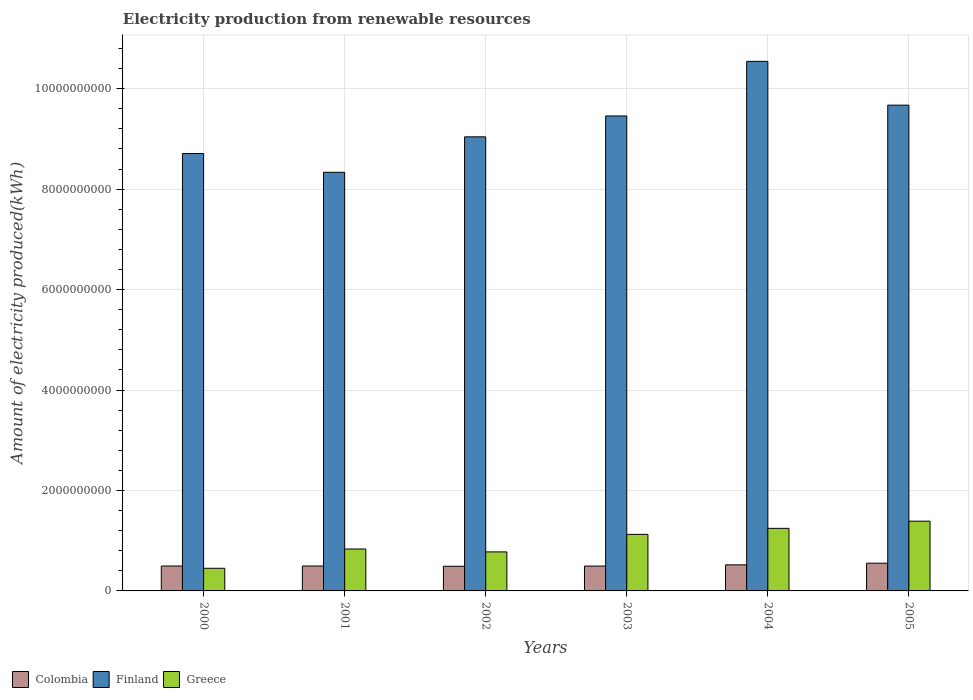How many groups of bars are there?
Ensure brevity in your answer.  6. Are the number of bars per tick equal to the number of legend labels?
Make the answer very short. Yes. Are the number of bars on each tick of the X-axis equal?
Ensure brevity in your answer.  Yes. How many bars are there on the 3rd tick from the left?
Offer a very short reply. 3. How many bars are there on the 4th tick from the right?
Your response must be concise. 3. What is the label of the 5th group of bars from the left?
Offer a very short reply. 2004. What is the amount of electricity produced in Finland in 2000?
Your answer should be very brief. 8.71e+09. Across all years, what is the maximum amount of electricity produced in Colombia?
Offer a terse response. 5.52e+08. Across all years, what is the minimum amount of electricity produced in Finland?
Offer a terse response. 8.34e+09. In which year was the amount of electricity produced in Colombia minimum?
Keep it short and to the point. 2002. What is the total amount of electricity produced in Greece in the graph?
Offer a very short reply. 5.82e+09. What is the difference between the amount of electricity produced in Finland in 2002 and that in 2003?
Make the answer very short. -4.16e+08. What is the difference between the amount of electricity produced in Colombia in 2003 and the amount of electricity produced in Finland in 2004?
Offer a terse response. -1.00e+1. What is the average amount of electricity produced in Colombia per year?
Make the answer very short. 5.08e+08. In the year 2004, what is the difference between the amount of electricity produced in Colombia and amount of electricity produced in Finland?
Provide a succinct answer. -1.00e+1. In how many years, is the amount of electricity produced in Finland greater than 5200000000 kWh?
Your response must be concise. 6. What is the ratio of the amount of electricity produced in Greece in 2001 to that in 2002?
Your answer should be very brief. 1.07. What is the difference between the highest and the second highest amount of electricity produced in Colombia?
Make the answer very short. 3.30e+07. What is the difference between the highest and the lowest amount of electricity produced in Greece?
Your answer should be compact. 9.38e+08. Is the sum of the amount of electricity produced in Finland in 2000 and 2005 greater than the maximum amount of electricity produced in Greece across all years?
Your response must be concise. Yes. What does the 3rd bar from the left in 2005 represents?
Provide a succinct answer. Greece. What does the 2nd bar from the right in 2000 represents?
Your answer should be compact. Finland. How many bars are there?
Provide a succinct answer. 18. What is the difference between two consecutive major ticks on the Y-axis?
Offer a very short reply. 2.00e+09. Are the values on the major ticks of Y-axis written in scientific E-notation?
Give a very brief answer. No. Where does the legend appear in the graph?
Offer a terse response. Bottom left. How are the legend labels stacked?
Your answer should be very brief. Horizontal. What is the title of the graph?
Your answer should be compact. Electricity production from renewable resources. What is the label or title of the X-axis?
Your answer should be compact. Years. What is the label or title of the Y-axis?
Ensure brevity in your answer.  Amount of electricity produced(kWh). What is the Amount of electricity produced(kWh) of Colombia in 2000?
Your response must be concise. 4.96e+08. What is the Amount of electricity produced(kWh) of Finland in 2000?
Offer a very short reply. 8.71e+09. What is the Amount of electricity produced(kWh) of Greece in 2000?
Ensure brevity in your answer.  4.51e+08. What is the Amount of electricity produced(kWh) in Colombia in 2001?
Make the answer very short. 4.96e+08. What is the Amount of electricity produced(kWh) of Finland in 2001?
Your response must be concise. 8.34e+09. What is the Amount of electricity produced(kWh) in Greece in 2001?
Provide a short and direct response. 8.35e+08. What is the Amount of electricity produced(kWh) of Colombia in 2002?
Your response must be concise. 4.91e+08. What is the Amount of electricity produced(kWh) of Finland in 2002?
Ensure brevity in your answer.  9.04e+09. What is the Amount of electricity produced(kWh) in Greece in 2002?
Give a very brief answer. 7.77e+08. What is the Amount of electricity produced(kWh) of Colombia in 2003?
Offer a terse response. 4.95e+08. What is the Amount of electricity produced(kWh) of Finland in 2003?
Make the answer very short. 9.46e+09. What is the Amount of electricity produced(kWh) of Greece in 2003?
Your answer should be compact. 1.13e+09. What is the Amount of electricity produced(kWh) of Colombia in 2004?
Offer a very short reply. 5.19e+08. What is the Amount of electricity produced(kWh) of Finland in 2004?
Make the answer very short. 1.05e+1. What is the Amount of electricity produced(kWh) in Greece in 2004?
Your answer should be compact. 1.25e+09. What is the Amount of electricity produced(kWh) in Colombia in 2005?
Your response must be concise. 5.52e+08. What is the Amount of electricity produced(kWh) of Finland in 2005?
Ensure brevity in your answer.  9.67e+09. What is the Amount of electricity produced(kWh) of Greece in 2005?
Offer a terse response. 1.39e+09. Across all years, what is the maximum Amount of electricity produced(kWh) of Colombia?
Provide a short and direct response. 5.52e+08. Across all years, what is the maximum Amount of electricity produced(kWh) in Finland?
Make the answer very short. 1.05e+1. Across all years, what is the maximum Amount of electricity produced(kWh) in Greece?
Ensure brevity in your answer.  1.39e+09. Across all years, what is the minimum Amount of electricity produced(kWh) in Colombia?
Provide a short and direct response. 4.91e+08. Across all years, what is the minimum Amount of electricity produced(kWh) in Finland?
Your answer should be very brief. 8.34e+09. Across all years, what is the minimum Amount of electricity produced(kWh) in Greece?
Provide a succinct answer. 4.51e+08. What is the total Amount of electricity produced(kWh) in Colombia in the graph?
Your response must be concise. 3.05e+09. What is the total Amount of electricity produced(kWh) in Finland in the graph?
Your answer should be compact. 5.58e+1. What is the total Amount of electricity produced(kWh) in Greece in the graph?
Offer a terse response. 5.82e+09. What is the difference between the Amount of electricity produced(kWh) of Finland in 2000 and that in 2001?
Your response must be concise. 3.74e+08. What is the difference between the Amount of electricity produced(kWh) in Greece in 2000 and that in 2001?
Provide a short and direct response. -3.84e+08. What is the difference between the Amount of electricity produced(kWh) of Colombia in 2000 and that in 2002?
Your answer should be very brief. 5.00e+06. What is the difference between the Amount of electricity produced(kWh) in Finland in 2000 and that in 2002?
Offer a terse response. -3.32e+08. What is the difference between the Amount of electricity produced(kWh) of Greece in 2000 and that in 2002?
Give a very brief answer. -3.26e+08. What is the difference between the Amount of electricity produced(kWh) of Colombia in 2000 and that in 2003?
Your answer should be very brief. 1.00e+06. What is the difference between the Amount of electricity produced(kWh) of Finland in 2000 and that in 2003?
Make the answer very short. -7.48e+08. What is the difference between the Amount of electricity produced(kWh) of Greece in 2000 and that in 2003?
Give a very brief answer. -6.75e+08. What is the difference between the Amount of electricity produced(kWh) of Colombia in 2000 and that in 2004?
Provide a succinct answer. -2.30e+07. What is the difference between the Amount of electricity produced(kWh) of Finland in 2000 and that in 2004?
Offer a very short reply. -1.84e+09. What is the difference between the Amount of electricity produced(kWh) in Greece in 2000 and that in 2004?
Your answer should be compact. -7.95e+08. What is the difference between the Amount of electricity produced(kWh) of Colombia in 2000 and that in 2005?
Ensure brevity in your answer.  -5.60e+07. What is the difference between the Amount of electricity produced(kWh) in Finland in 2000 and that in 2005?
Make the answer very short. -9.63e+08. What is the difference between the Amount of electricity produced(kWh) in Greece in 2000 and that in 2005?
Keep it short and to the point. -9.38e+08. What is the difference between the Amount of electricity produced(kWh) of Finland in 2001 and that in 2002?
Your answer should be compact. -7.06e+08. What is the difference between the Amount of electricity produced(kWh) in Greece in 2001 and that in 2002?
Your response must be concise. 5.80e+07. What is the difference between the Amount of electricity produced(kWh) in Finland in 2001 and that in 2003?
Ensure brevity in your answer.  -1.12e+09. What is the difference between the Amount of electricity produced(kWh) of Greece in 2001 and that in 2003?
Provide a succinct answer. -2.91e+08. What is the difference between the Amount of electricity produced(kWh) in Colombia in 2001 and that in 2004?
Your answer should be compact. -2.30e+07. What is the difference between the Amount of electricity produced(kWh) of Finland in 2001 and that in 2004?
Provide a succinct answer. -2.21e+09. What is the difference between the Amount of electricity produced(kWh) in Greece in 2001 and that in 2004?
Provide a succinct answer. -4.11e+08. What is the difference between the Amount of electricity produced(kWh) of Colombia in 2001 and that in 2005?
Your answer should be compact. -5.60e+07. What is the difference between the Amount of electricity produced(kWh) in Finland in 2001 and that in 2005?
Provide a succinct answer. -1.34e+09. What is the difference between the Amount of electricity produced(kWh) in Greece in 2001 and that in 2005?
Your answer should be compact. -5.54e+08. What is the difference between the Amount of electricity produced(kWh) of Colombia in 2002 and that in 2003?
Give a very brief answer. -4.00e+06. What is the difference between the Amount of electricity produced(kWh) of Finland in 2002 and that in 2003?
Your answer should be very brief. -4.16e+08. What is the difference between the Amount of electricity produced(kWh) of Greece in 2002 and that in 2003?
Provide a succinct answer. -3.49e+08. What is the difference between the Amount of electricity produced(kWh) of Colombia in 2002 and that in 2004?
Keep it short and to the point. -2.80e+07. What is the difference between the Amount of electricity produced(kWh) of Finland in 2002 and that in 2004?
Your answer should be compact. -1.50e+09. What is the difference between the Amount of electricity produced(kWh) in Greece in 2002 and that in 2004?
Your response must be concise. -4.69e+08. What is the difference between the Amount of electricity produced(kWh) in Colombia in 2002 and that in 2005?
Offer a terse response. -6.10e+07. What is the difference between the Amount of electricity produced(kWh) of Finland in 2002 and that in 2005?
Offer a very short reply. -6.31e+08. What is the difference between the Amount of electricity produced(kWh) of Greece in 2002 and that in 2005?
Provide a short and direct response. -6.12e+08. What is the difference between the Amount of electricity produced(kWh) of Colombia in 2003 and that in 2004?
Offer a terse response. -2.40e+07. What is the difference between the Amount of electricity produced(kWh) of Finland in 2003 and that in 2004?
Your response must be concise. -1.09e+09. What is the difference between the Amount of electricity produced(kWh) in Greece in 2003 and that in 2004?
Your answer should be compact. -1.20e+08. What is the difference between the Amount of electricity produced(kWh) of Colombia in 2003 and that in 2005?
Provide a short and direct response. -5.70e+07. What is the difference between the Amount of electricity produced(kWh) in Finland in 2003 and that in 2005?
Make the answer very short. -2.15e+08. What is the difference between the Amount of electricity produced(kWh) in Greece in 2003 and that in 2005?
Keep it short and to the point. -2.63e+08. What is the difference between the Amount of electricity produced(kWh) in Colombia in 2004 and that in 2005?
Provide a succinct answer. -3.30e+07. What is the difference between the Amount of electricity produced(kWh) in Finland in 2004 and that in 2005?
Your response must be concise. 8.72e+08. What is the difference between the Amount of electricity produced(kWh) in Greece in 2004 and that in 2005?
Provide a short and direct response. -1.43e+08. What is the difference between the Amount of electricity produced(kWh) in Colombia in 2000 and the Amount of electricity produced(kWh) in Finland in 2001?
Keep it short and to the point. -7.84e+09. What is the difference between the Amount of electricity produced(kWh) in Colombia in 2000 and the Amount of electricity produced(kWh) in Greece in 2001?
Keep it short and to the point. -3.39e+08. What is the difference between the Amount of electricity produced(kWh) in Finland in 2000 and the Amount of electricity produced(kWh) in Greece in 2001?
Provide a short and direct response. 7.88e+09. What is the difference between the Amount of electricity produced(kWh) in Colombia in 2000 and the Amount of electricity produced(kWh) in Finland in 2002?
Ensure brevity in your answer.  -8.55e+09. What is the difference between the Amount of electricity produced(kWh) in Colombia in 2000 and the Amount of electricity produced(kWh) in Greece in 2002?
Your response must be concise. -2.81e+08. What is the difference between the Amount of electricity produced(kWh) in Finland in 2000 and the Amount of electricity produced(kWh) in Greece in 2002?
Your answer should be very brief. 7.93e+09. What is the difference between the Amount of electricity produced(kWh) in Colombia in 2000 and the Amount of electricity produced(kWh) in Finland in 2003?
Provide a short and direct response. -8.96e+09. What is the difference between the Amount of electricity produced(kWh) in Colombia in 2000 and the Amount of electricity produced(kWh) in Greece in 2003?
Offer a very short reply. -6.30e+08. What is the difference between the Amount of electricity produced(kWh) in Finland in 2000 and the Amount of electricity produced(kWh) in Greece in 2003?
Give a very brief answer. 7.58e+09. What is the difference between the Amount of electricity produced(kWh) of Colombia in 2000 and the Amount of electricity produced(kWh) of Finland in 2004?
Offer a very short reply. -1.00e+1. What is the difference between the Amount of electricity produced(kWh) of Colombia in 2000 and the Amount of electricity produced(kWh) of Greece in 2004?
Offer a very short reply. -7.50e+08. What is the difference between the Amount of electricity produced(kWh) of Finland in 2000 and the Amount of electricity produced(kWh) of Greece in 2004?
Offer a terse response. 7.46e+09. What is the difference between the Amount of electricity produced(kWh) of Colombia in 2000 and the Amount of electricity produced(kWh) of Finland in 2005?
Make the answer very short. -9.18e+09. What is the difference between the Amount of electricity produced(kWh) in Colombia in 2000 and the Amount of electricity produced(kWh) in Greece in 2005?
Give a very brief answer. -8.93e+08. What is the difference between the Amount of electricity produced(kWh) in Finland in 2000 and the Amount of electricity produced(kWh) in Greece in 2005?
Provide a short and direct response. 7.32e+09. What is the difference between the Amount of electricity produced(kWh) in Colombia in 2001 and the Amount of electricity produced(kWh) in Finland in 2002?
Provide a succinct answer. -8.55e+09. What is the difference between the Amount of electricity produced(kWh) in Colombia in 2001 and the Amount of electricity produced(kWh) in Greece in 2002?
Keep it short and to the point. -2.81e+08. What is the difference between the Amount of electricity produced(kWh) in Finland in 2001 and the Amount of electricity produced(kWh) in Greece in 2002?
Ensure brevity in your answer.  7.56e+09. What is the difference between the Amount of electricity produced(kWh) in Colombia in 2001 and the Amount of electricity produced(kWh) in Finland in 2003?
Offer a very short reply. -8.96e+09. What is the difference between the Amount of electricity produced(kWh) in Colombia in 2001 and the Amount of electricity produced(kWh) in Greece in 2003?
Make the answer very short. -6.30e+08. What is the difference between the Amount of electricity produced(kWh) in Finland in 2001 and the Amount of electricity produced(kWh) in Greece in 2003?
Offer a very short reply. 7.21e+09. What is the difference between the Amount of electricity produced(kWh) in Colombia in 2001 and the Amount of electricity produced(kWh) in Finland in 2004?
Offer a very short reply. -1.00e+1. What is the difference between the Amount of electricity produced(kWh) of Colombia in 2001 and the Amount of electricity produced(kWh) of Greece in 2004?
Offer a terse response. -7.50e+08. What is the difference between the Amount of electricity produced(kWh) in Finland in 2001 and the Amount of electricity produced(kWh) in Greece in 2004?
Your answer should be compact. 7.09e+09. What is the difference between the Amount of electricity produced(kWh) in Colombia in 2001 and the Amount of electricity produced(kWh) in Finland in 2005?
Your response must be concise. -9.18e+09. What is the difference between the Amount of electricity produced(kWh) of Colombia in 2001 and the Amount of electricity produced(kWh) of Greece in 2005?
Keep it short and to the point. -8.93e+08. What is the difference between the Amount of electricity produced(kWh) in Finland in 2001 and the Amount of electricity produced(kWh) in Greece in 2005?
Your response must be concise. 6.95e+09. What is the difference between the Amount of electricity produced(kWh) in Colombia in 2002 and the Amount of electricity produced(kWh) in Finland in 2003?
Provide a succinct answer. -8.97e+09. What is the difference between the Amount of electricity produced(kWh) in Colombia in 2002 and the Amount of electricity produced(kWh) in Greece in 2003?
Offer a very short reply. -6.35e+08. What is the difference between the Amount of electricity produced(kWh) of Finland in 2002 and the Amount of electricity produced(kWh) of Greece in 2003?
Give a very brief answer. 7.92e+09. What is the difference between the Amount of electricity produced(kWh) of Colombia in 2002 and the Amount of electricity produced(kWh) of Finland in 2004?
Provide a succinct answer. -1.01e+1. What is the difference between the Amount of electricity produced(kWh) in Colombia in 2002 and the Amount of electricity produced(kWh) in Greece in 2004?
Ensure brevity in your answer.  -7.55e+08. What is the difference between the Amount of electricity produced(kWh) in Finland in 2002 and the Amount of electricity produced(kWh) in Greece in 2004?
Provide a short and direct response. 7.80e+09. What is the difference between the Amount of electricity produced(kWh) of Colombia in 2002 and the Amount of electricity produced(kWh) of Finland in 2005?
Give a very brief answer. -9.18e+09. What is the difference between the Amount of electricity produced(kWh) in Colombia in 2002 and the Amount of electricity produced(kWh) in Greece in 2005?
Give a very brief answer. -8.98e+08. What is the difference between the Amount of electricity produced(kWh) of Finland in 2002 and the Amount of electricity produced(kWh) of Greece in 2005?
Keep it short and to the point. 7.65e+09. What is the difference between the Amount of electricity produced(kWh) of Colombia in 2003 and the Amount of electricity produced(kWh) of Finland in 2004?
Your response must be concise. -1.00e+1. What is the difference between the Amount of electricity produced(kWh) in Colombia in 2003 and the Amount of electricity produced(kWh) in Greece in 2004?
Your response must be concise. -7.51e+08. What is the difference between the Amount of electricity produced(kWh) in Finland in 2003 and the Amount of electricity produced(kWh) in Greece in 2004?
Keep it short and to the point. 8.21e+09. What is the difference between the Amount of electricity produced(kWh) in Colombia in 2003 and the Amount of electricity produced(kWh) in Finland in 2005?
Your answer should be compact. -9.18e+09. What is the difference between the Amount of electricity produced(kWh) of Colombia in 2003 and the Amount of electricity produced(kWh) of Greece in 2005?
Provide a short and direct response. -8.94e+08. What is the difference between the Amount of electricity produced(kWh) of Finland in 2003 and the Amount of electricity produced(kWh) of Greece in 2005?
Make the answer very short. 8.07e+09. What is the difference between the Amount of electricity produced(kWh) in Colombia in 2004 and the Amount of electricity produced(kWh) in Finland in 2005?
Your answer should be compact. -9.15e+09. What is the difference between the Amount of electricity produced(kWh) of Colombia in 2004 and the Amount of electricity produced(kWh) of Greece in 2005?
Provide a short and direct response. -8.70e+08. What is the difference between the Amount of electricity produced(kWh) in Finland in 2004 and the Amount of electricity produced(kWh) in Greece in 2005?
Your response must be concise. 9.16e+09. What is the average Amount of electricity produced(kWh) in Colombia per year?
Your answer should be very brief. 5.08e+08. What is the average Amount of electricity produced(kWh) in Finland per year?
Provide a succinct answer. 9.29e+09. What is the average Amount of electricity produced(kWh) of Greece per year?
Provide a succinct answer. 9.71e+08. In the year 2000, what is the difference between the Amount of electricity produced(kWh) in Colombia and Amount of electricity produced(kWh) in Finland?
Provide a short and direct response. -8.21e+09. In the year 2000, what is the difference between the Amount of electricity produced(kWh) of Colombia and Amount of electricity produced(kWh) of Greece?
Offer a very short reply. 4.50e+07. In the year 2000, what is the difference between the Amount of electricity produced(kWh) in Finland and Amount of electricity produced(kWh) in Greece?
Give a very brief answer. 8.26e+09. In the year 2001, what is the difference between the Amount of electricity produced(kWh) in Colombia and Amount of electricity produced(kWh) in Finland?
Your answer should be very brief. -7.84e+09. In the year 2001, what is the difference between the Amount of electricity produced(kWh) in Colombia and Amount of electricity produced(kWh) in Greece?
Ensure brevity in your answer.  -3.39e+08. In the year 2001, what is the difference between the Amount of electricity produced(kWh) in Finland and Amount of electricity produced(kWh) in Greece?
Ensure brevity in your answer.  7.50e+09. In the year 2002, what is the difference between the Amount of electricity produced(kWh) in Colombia and Amount of electricity produced(kWh) in Finland?
Offer a terse response. -8.55e+09. In the year 2002, what is the difference between the Amount of electricity produced(kWh) in Colombia and Amount of electricity produced(kWh) in Greece?
Your response must be concise. -2.86e+08. In the year 2002, what is the difference between the Amount of electricity produced(kWh) in Finland and Amount of electricity produced(kWh) in Greece?
Your response must be concise. 8.26e+09. In the year 2003, what is the difference between the Amount of electricity produced(kWh) in Colombia and Amount of electricity produced(kWh) in Finland?
Offer a very short reply. -8.96e+09. In the year 2003, what is the difference between the Amount of electricity produced(kWh) of Colombia and Amount of electricity produced(kWh) of Greece?
Provide a short and direct response. -6.31e+08. In the year 2003, what is the difference between the Amount of electricity produced(kWh) of Finland and Amount of electricity produced(kWh) of Greece?
Provide a short and direct response. 8.33e+09. In the year 2004, what is the difference between the Amount of electricity produced(kWh) of Colombia and Amount of electricity produced(kWh) of Finland?
Give a very brief answer. -1.00e+1. In the year 2004, what is the difference between the Amount of electricity produced(kWh) of Colombia and Amount of electricity produced(kWh) of Greece?
Keep it short and to the point. -7.27e+08. In the year 2004, what is the difference between the Amount of electricity produced(kWh) in Finland and Amount of electricity produced(kWh) in Greece?
Ensure brevity in your answer.  9.30e+09. In the year 2005, what is the difference between the Amount of electricity produced(kWh) in Colombia and Amount of electricity produced(kWh) in Finland?
Your answer should be compact. -9.12e+09. In the year 2005, what is the difference between the Amount of electricity produced(kWh) of Colombia and Amount of electricity produced(kWh) of Greece?
Offer a very short reply. -8.37e+08. In the year 2005, what is the difference between the Amount of electricity produced(kWh) in Finland and Amount of electricity produced(kWh) in Greece?
Make the answer very short. 8.28e+09. What is the ratio of the Amount of electricity produced(kWh) in Colombia in 2000 to that in 2001?
Offer a very short reply. 1. What is the ratio of the Amount of electricity produced(kWh) in Finland in 2000 to that in 2001?
Offer a terse response. 1.04. What is the ratio of the Amount of electricity produced(kWh) of Greece in 2000 to that in 2001?
Offer a very short reply. 0.54. What is the ratio of the Amount of electricity produced(kWh) in Colombia in 2000 to that in 2002?
Provide a succinct answer. 1.01. What is the ratio of the Amount of electricity produced(kWh) in Finland in 2000 to that in 2002?
Your response must be concise. 0.96. What is the ratio of the Amount of electricity produced(kWh) of Greece in 2000 to that in 2002?
Your response must be concise. 0.58. What is the ratio of the Amount of electricity produced(kWh) in Finland in 2000 to that in 2003?
Your answer should be compact. 0.92. What is the ratio of the Amount of electricity produced(kWh) in Greece in 2000 to that in 2003?
Offer a very short reply. 0.4. What is the ratio of the Amount of electricity produced(kWh) of Colombia in 2000 to that in 2004?
Your answer should be compact. 0.96. What is the ratio of the Amount of electricity produced(kWh) of Finland in 2000 to that in 2004?
Give a very brief answer. 0.83. What is the ratio of the Amount of electricity produced(kWh) of Greece in 2000 to that in 2004?
Your answer should be very brief. 0.36. What is the ratio of the Amount of electricity produced(kWh) in Colombia in 2000 to that in 2005?
Provide a short and direct response. 0.9. What is the ratio of the Amount of electricity produced(kWh) of Finland in 2000 to that in 2005?
Your response must be concise. 0.9. What is the ratio of the Amount of electricity produced(kWh) in Greece in 2000 to that in 2005?
Offer a very short reply. 0.32. What is the ratio of the Amount of electricity produced(kWh) in Colombia in 2001 to that in 2002?
Offer a terse response. 1.01. What is the ratio of the Amount of electricity produced(kWh) of Finland in 2001 to that in 2002?
Provide a short and direct response. 0.92. What is the ratio of the Amount of electricity produced(kWh) of Greece in 2001 to that in 2002?
Provide a short and direct response. 1.07. What is the ratio of the Amount of electricity produced(kWh) in Finland in 2001 to that in 2003?
Your answer should be compact. 0.88. What is the ratio of the Amount of electricity produced(kWh) in Greece in 2001 to that in 2003?
Offer a very short reply. 0.74. What is the ratio of the Amount of electricity produced(kWh) of Colombia in 2001 to that in 2004?
Your answer should be very brief. 0.96. What is the ratio of the Amount of electricity produced(kWh) in Finland in 2001 to that in 2004?
Make the answer very short. 0.79. What is the ratio of the Amount of electricity produced(kWh) of Greece in 2001 to that in 2004?
Keep it short and to the point. 0.67. What is the ratio of the Amount of electricity produced(kWh) of Colombia in 2001 to that in 2005?
Provide a succinct answer. 0.9. What is the ratio of the Amount of electricity produced(kWh) of Finland in 2001 to that in 2005?
Your response must be concise. 0.86. What is the ratio of the Amount of electricity produced(kWh) of Greece in 2001 to that in 2005?
Provide a short and direct response. 0.6. What is the ratio of the Amount of electricity produced(kWh) of Finland in 2002 to that in 2003?
Offer a terse response. 0.96. What is the ratio of the Amount of electricity produced(kWh) of Greece in 2002 to that in 2003?
Keep it short and to the point. 0.69. What is the ratio of the Amount of electricity produced(kWh) of Colombia in 2002 to that in 2004?
Provide a short and direct response. 0.95. What is the ratio of the Amount of electricity produced(kWh) of Finland in 2002 to that in 2004?
Your response must be concise. 0.86. What is the ratio of the Amount of electricity produced(kWh) of Greece in 2002 to that in 2004?
Provide a succinct answer. 0.62. What is the ratio of the Amount of electricity produced(kWh) of Colombia in 2002 to that in 2005?
Give a very brief answer. 0.89. What is the ratio of the Amount of electricity produced(kWh) in Finland in 2002 to that in 2005?
Keep it short and to the point. 0.93. What is the ratio of the Amount of electricity produced(kWh) of Greece in 2002 to that in 2005?
Your answer should be very brief. 0.56. What is the ratio of the Amount of electricity produced(kWh) of Colombia in 2003 to that in 2004?
Ensure brevity in your answer.  0.95. What is the ratio of the Amount of electricity produced(kWh) of Finland in 2003 to that in 2004?
Offer a very short reply. 0.9. What is the ratio of the Amount of electricity produced(kWh) in Greece in 2003 to that in 2004?
Provide a short and direct response. 0.9. What is the ratio of the Amount of electricity produced(kWh) in Colombia in 2003 to that in 2005?
Your answer should be compact. 0.9. What is the ratio of the Amount of electricity produced(kWh) in Finland in 2003 to that in 2005?
Your answer should be very brief. 0.98. What is the ratio of the Amount of electricity produced(kWh) of Greece in 2003 to that in 2005?
Your answer should be very brief. 0.81. What is the ratio of the Amount of electricity produced(kWh) in Colombia in 2004 to that in 2005?
Offer a terse response. 0.94. What is the ratio of the Amount of electricity produced(kWh) in Finland in 2004 to that in 2005?
Your answer should be compact. 1.09. What is the ratio of the Amount of electricity produced(kWh) in Greece in 2004 to that in 2005?
Your response must be concise. 0.9. What is the difference between the highest and the second highest Amount of electricity produced(kWh) of Colombia?
Your response must be concise. 3.30e+07. What is the difference between the highest and the second highest Amount of electricity produced(kWh) in Finland?
Provide a short and direct response. 8.72e+08. What is the difference between the highest and the second highest Amount of electricity produced(kWh) in Greece?
Make the answer very short. 1.43e+08. What is the difference between the highest and the lowest Amount of electricity produced(kWh) in Colombia?
Give a very brief answer. 6.10e+07. What is the difference between the highest and the lowest Amount of electricity produced(kWh) in Finland?
Provide a succinct answer. 2.21e+09. What is the difference between the highest and the lowest Amount of electricity produced(kWh) of Greece?
Your answer should be compact. 9.38e+08. 